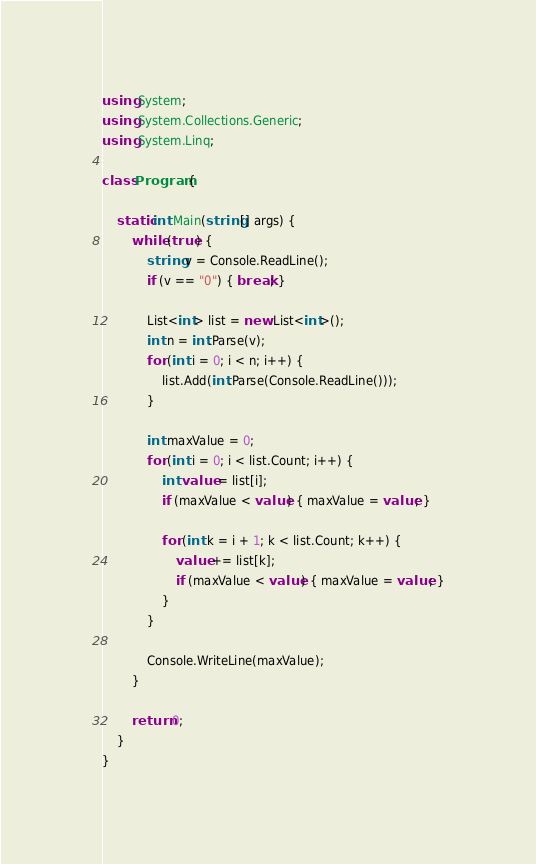<code> <loc_0><loc_0><loc_500><loc_500><_C#_>using System;
using System.Collections.Generic;
using System.Linq;

class Program {

    static int Main(string[] args) {
        while (true) {
            string v = Console.ReadLine();
            if (v == "0") { break; }

            List<int> list = new List<int>();
            int n = int.Parse(v);
            for (int i = 0; i < n; i++) {
                list.Add(int.Parse(Console.ReadLine()));
            }

            int maxValue = 0;
            for (int i = 0; i < list.Count; i++) {
                int value = list[i];
                if (maxValue < value) { maxValue = value; }

                for (int k = i + 1; k < list.Count; k++) {
                    value += list[k];
                    if (maxValue < value) { maxValue = value; }
                }
            }

            Console.WriteLine(maxValue);
        }

        return 0;
    }
}

</code> 